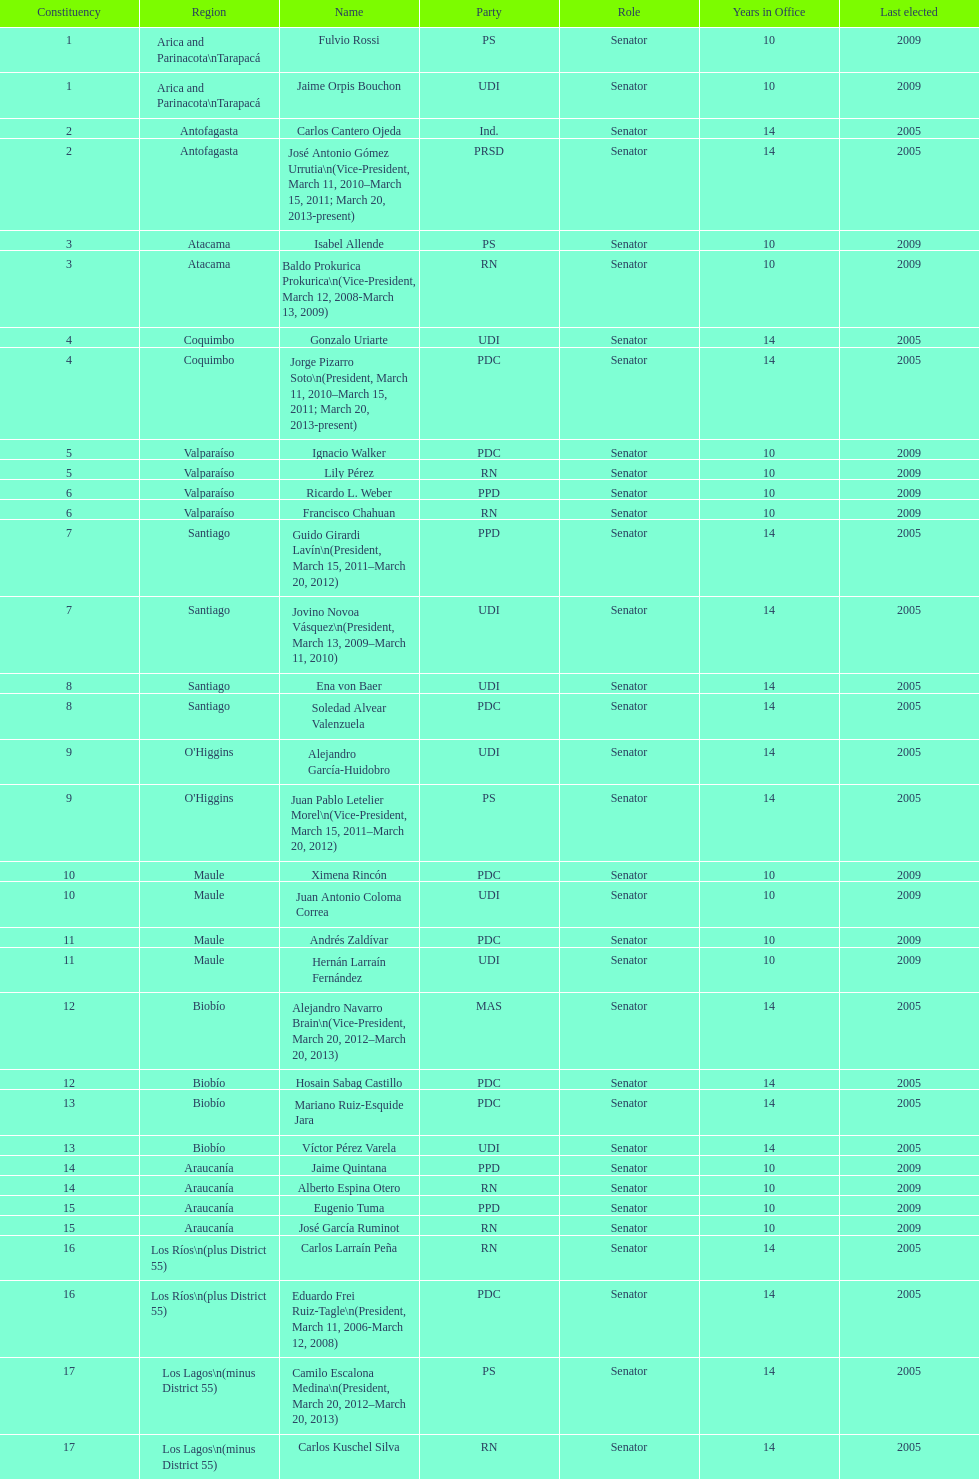Which region is listed below atacama? Coquimbo. 